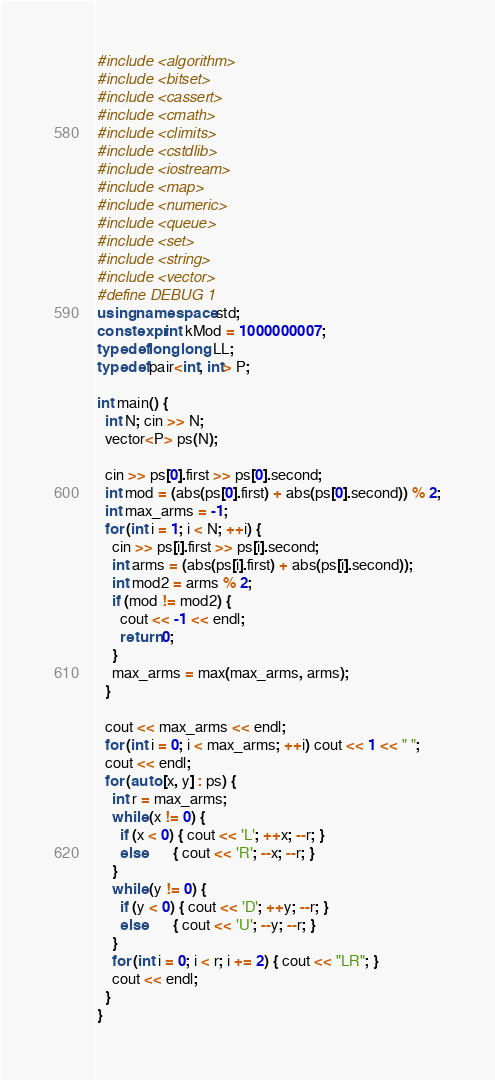Convert code to text. <code><loc_0><loc_0><loc_500><loc_500><_C++_>#include <algorithm>
#include <bitset>
#include <cassert>
#include <cmath>
#include <climits>
#include <cstdlib>
#include <iostream>
#include <map>
#include <numeric>
#include <queue>
#include <set>
#include <string>
#include <vector>
#define DEBUG 1
using namespace std;
constexpr int kMod = 1000000007;
typedef long long LL;
typedef pair<int, int> P;

int main() {
  int N; cin >> N;
  vector<P> ps(N);

  cin >> ps[0].first >> ps[0].second;
  int mod = (abs(ps[0].first) + abs(ps[0].second)) % 2;
  int max_arms = -1;
  for (int i = 1; i < N; ++i) {
    cin >> ps[i].first >> ps[i].second;
    int arms = (abs(ps[i].first) + abs(ps[i].second));
    int mod2 = arms % 2;
    if (mod != mod2) {
      cout << -1 << endl;
      return 0;
    }
    max_arms = max(max_arms, arms);
  }

  cout << max_arms << endl;
  for (int i = 0; i < max_arms; ++i) cout << 1 << " ";
  cout << endl;
  for (auto [x, y] : ps) {
    int r = max_arms;
    while (x != 0) {
      if (x < 0) { cout << 'L'; ++x; --r; }
      else       { cout << 'R'; --x; --r; }
    }
    while (y != 0) {
      if (y < 0) { cout << 'D'; ++y; --r; }
      else       { cout << 'U'; --y; --r; }
    }
    for (int i = 0; i < r; i += 2) { cout << "LR"; }
    cout << endl;
  }
}
</code> 